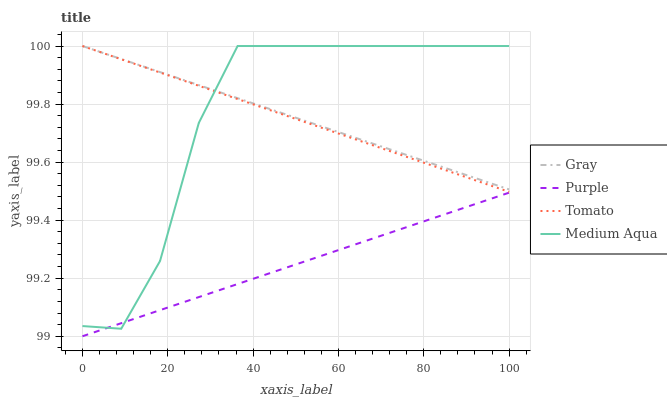Does Purple have the minimum area under the curve?
Answer yes or no. Yes. Does Medium Aqua have the maximum area under the curve?
Answer yes or no. Yes. Does Gray have the minimum area under the curve?
Answer yes or no. No. Does Gray have the maximum area under the curve?
Answer yes or no. No. Is Purple the smoothest?
Answer yes or no. Yes. Is Medium Aqua the roughest?
Answer yes or no. Yes. Is Gray the smoothest?
Answer yes or no. No. Is Gray the roughest?
Answer yes or no. No. Does Purple have the lowest value?
Answer yes or no. Yes. Does Tomato have the lowest value?
Answer yes or no. No. Does Medium Aqua have the highest value?
Answer yes or no. Yes. Is Purple less than Gray?
Answer yes or no. Yes. Is Gray greater than Purple?
Answer yes or no. Yes. Does Medium Aqua intersect Purple?
Answer yes or no. Yes. Is Medium Aqua less than Purple?
Answer yes or no. No. Is Medium Aqua greater than Purple?
Answer yes or no. No. Does Purple intersect Gray?
Answer yes or no. No. 